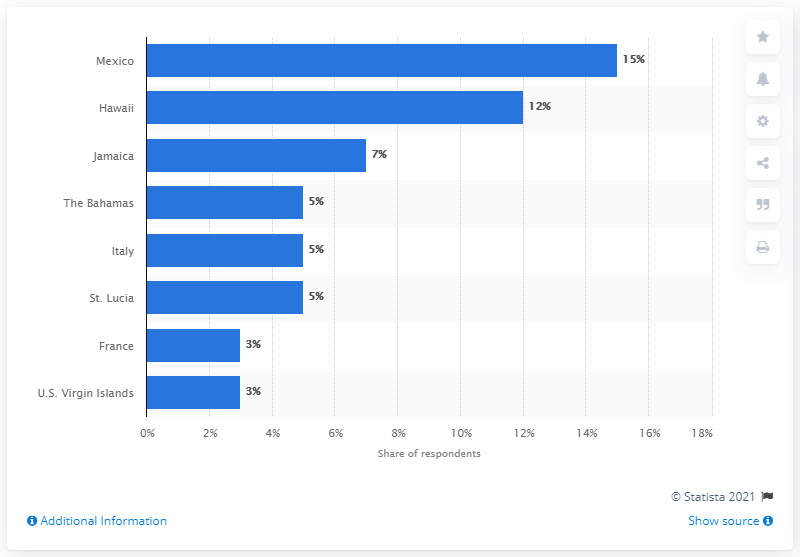Which spots in Hawaii are particularly favored by honeymooners? Honeymooners often favor destinations such as Maui for its romantic sunsets, the Big Island for its diverse climate zones, and Kauai for its lush landscapes and dramatic cliffs along the Napali Coast. 